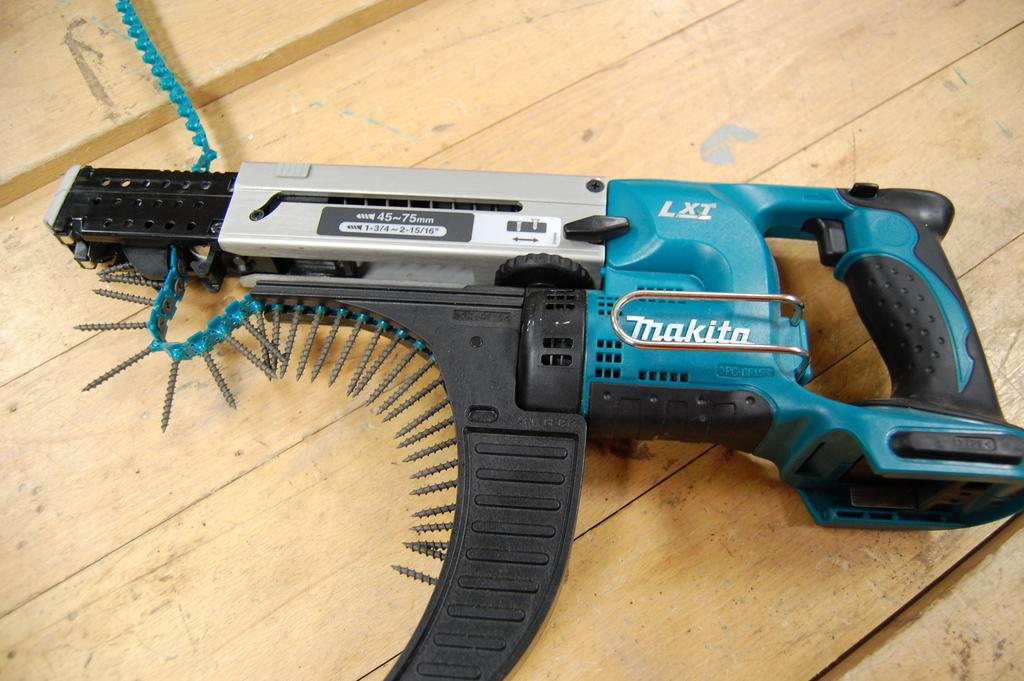What tool is visible in the image? There is a screw gun in the image. What type of surface is the screw gun placed on? The screw gun is on a wooden surface. What type of metal is used to create the scene in the image? There is no scene present in the image, and therefore no metal is used to create it. 